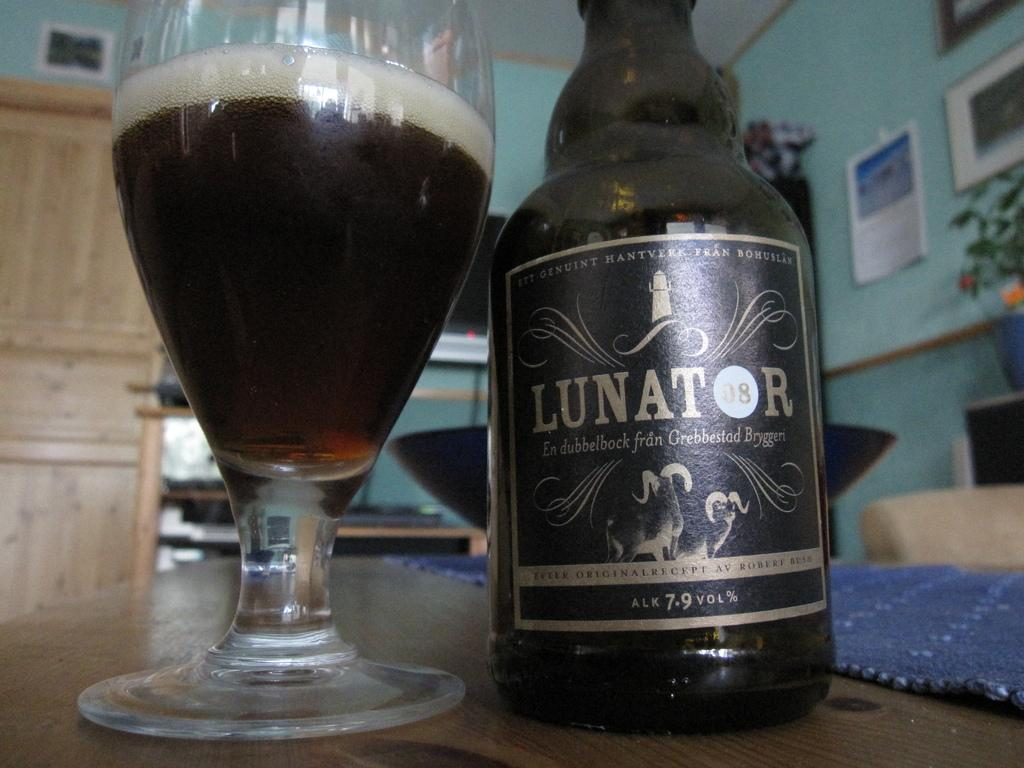<image>
Create a compact narrative representing the image presented. Bottle of alcohol with a label that says LUNATOR next to a cup of alcohol. 